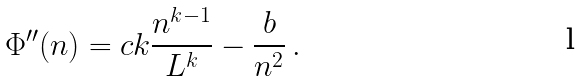<formula> <loc_0><loc_0><loc_500><loc_500>\Phi ^ { \prime \prime } ( n ) = c k \frac { n ^ { k - 1 } } { L ^ { k } } - \frac { b } { n ^ { 2 } } \, .</formula> 